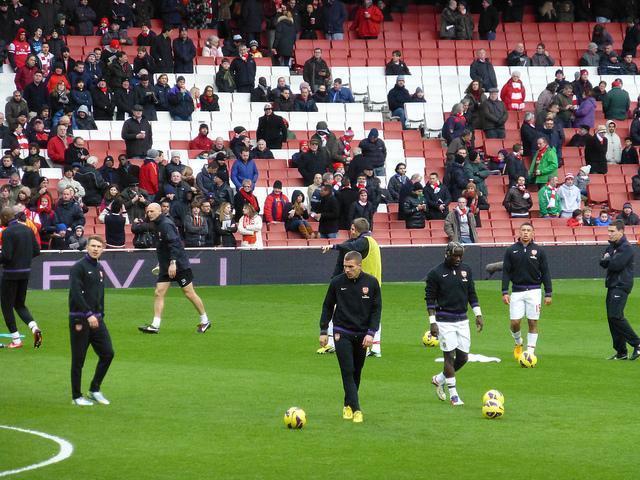How many people are wearing pants on the field?
Give a very brief answer. 4. How many people are there?
Give a very brief answer. 8. 